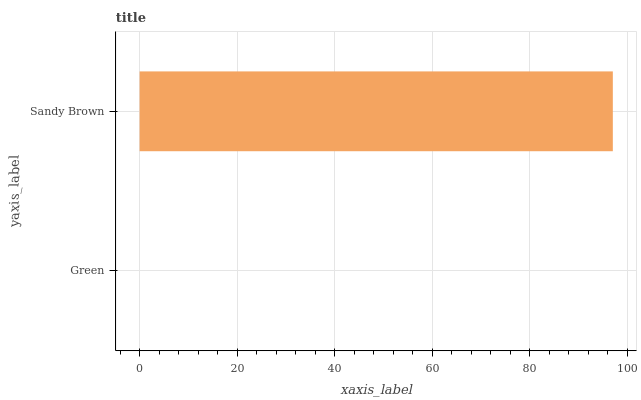Is Green the minimum?
Answer yes or no. Yes. Is Sandy Brown the maximum?
Answer yes or no. Yes. Is Sandy Brown the minimum?
Answer yes or no. No. Is Sandy Brown greater than Green?
Answer yes or no. Yes. Is Green less than Sandy Brown?
Answer yes or no. Yes. Is Green greater than Sandy Brown?
Answer yes or no. No. Is Sandy Brown less than Green?
Answer yes or no. No. Is Sandy Brown the high median?
Answer yes or no. Yes. Is Green the low median?
Answer yes or no. Yes. Is Green the high median?
Answer yes or no. No. Is Sandy Brown the low median?
Answer yes or no. No. 